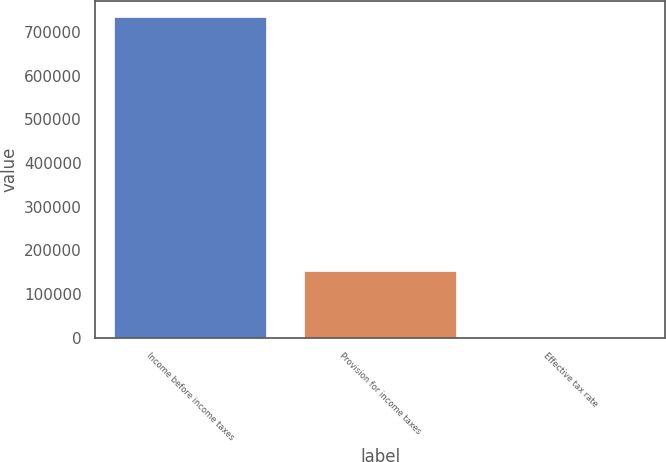Convert chart to OTSL. <chart><loc_0><loc_0><loc_500><loc_500><bar_chart><fcel>Income before income taxes<fcel>Provision for income taxes<fcel>Effective tax rate<nl><fcel>734461<fcel>151706<fcel>20.7<nl></chart> 